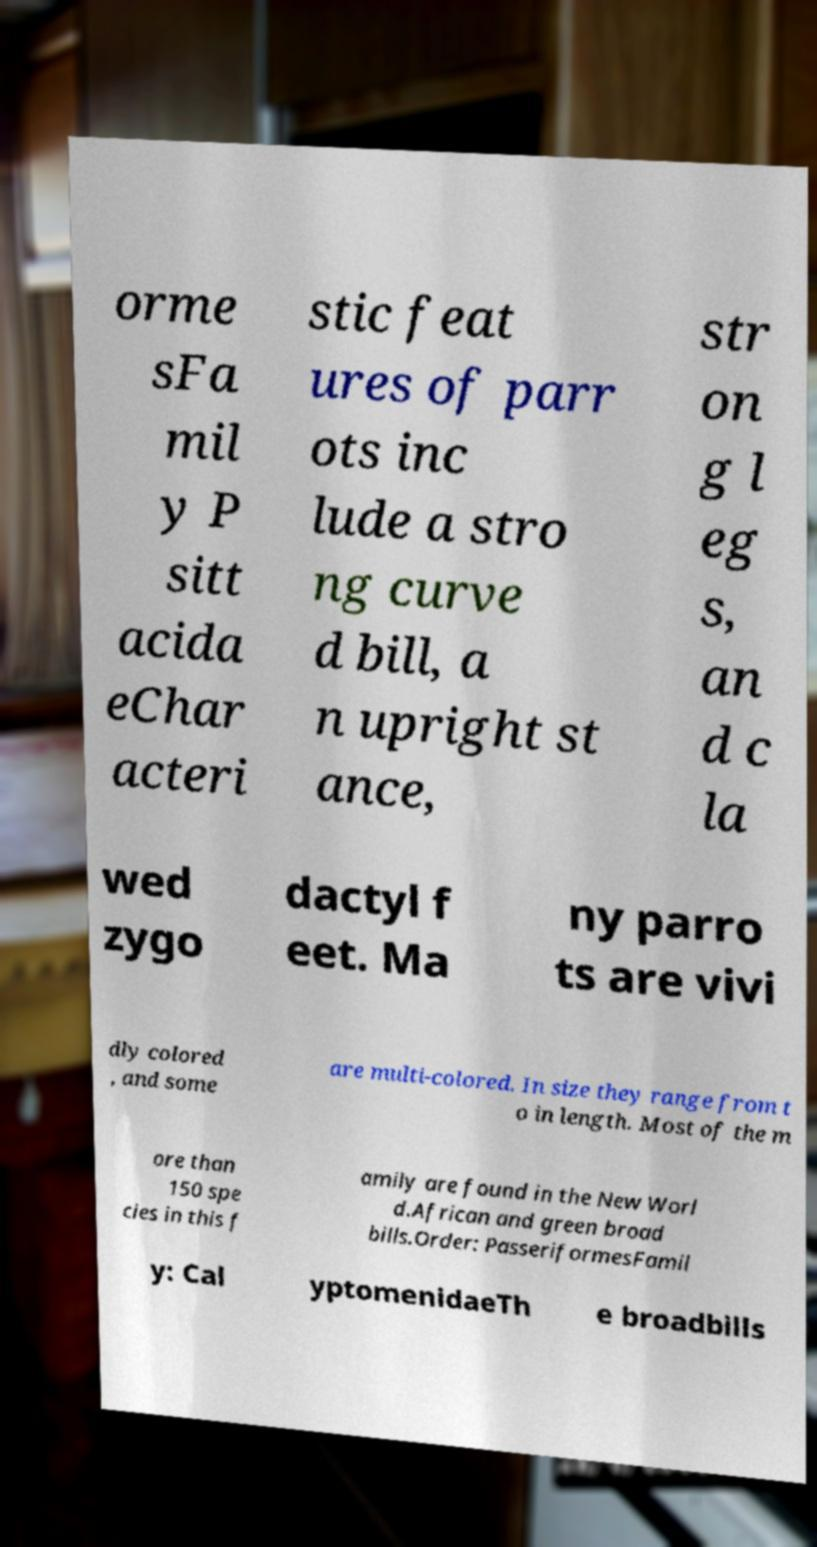There's text embedded in this image that I need extracted. Can you transcribe it verbatim? orme sFa mil y P sitt acida eChar acteri stic feat ures of parr ots inc lude a stro ng curve d bill, a n upright st ance, str on g l eg s, an d c la wed zygo dactyl f eet. Ma ny parro ts are vivi dly colored , and some are multi-colored. In size they range from t o in length. Most of the m ore than 150 spe cies in this f amily are found in the New Worl d.African and green broad bills.Order: PasseriformesFamil y: Cal yptomenidaeTh e broadbills 